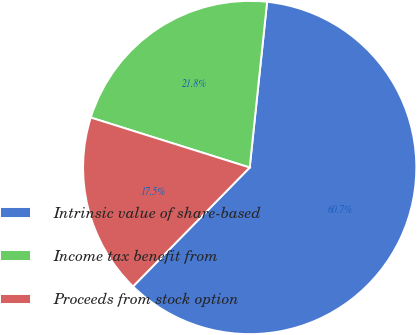<chart> <loc_0><loc_0><loc_500><loc_500><pie_chart><fcel>Intrinsic value of share-based<fcel>Income tax benefit from<fcel>Proceeds from stock option<nl><fcel>60.69%<fcel>21.82%<fcel>17.5%<nl></chart> 